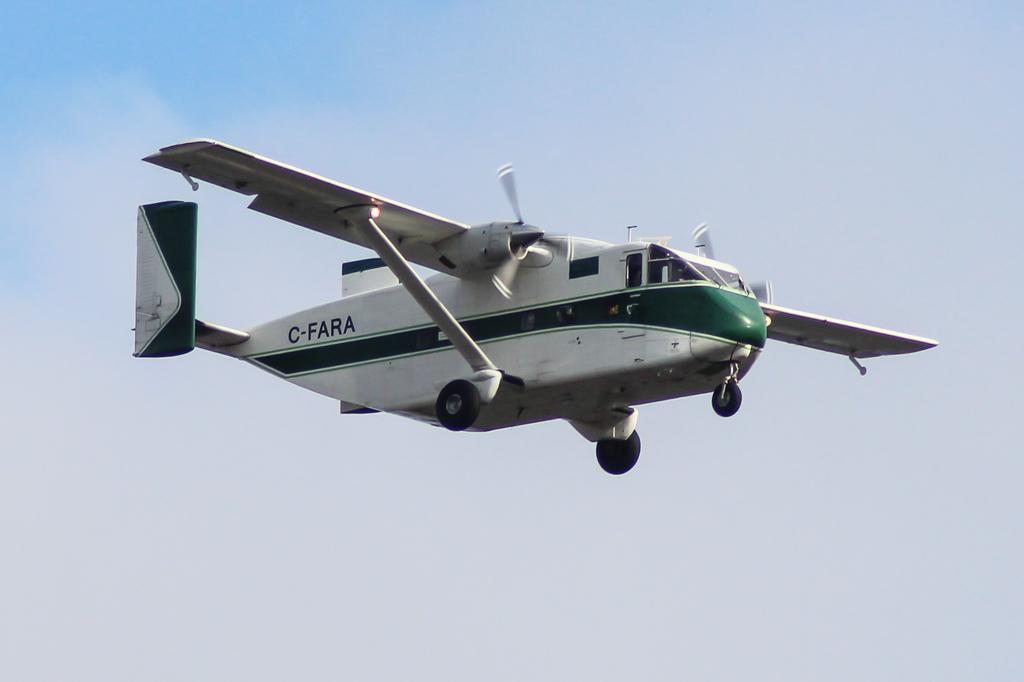What is written on this plane?
Your answer should be compact. C-fara. 